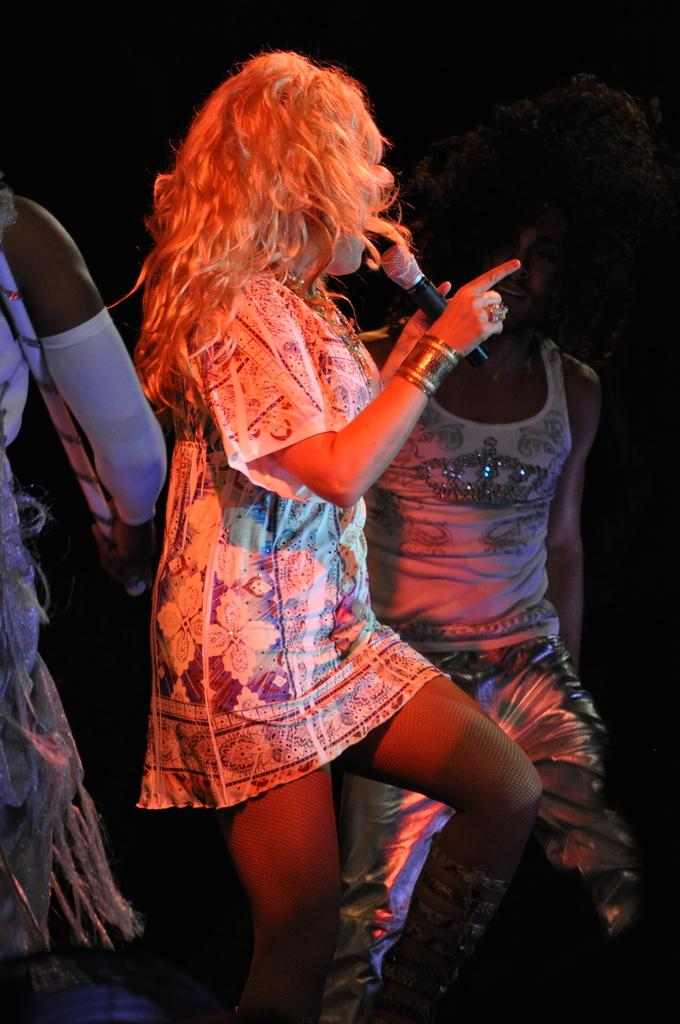How many people are in the image? There are a few people in the image. What is one person doing in the image? One person is holding a microphone. What can be observed about the background of the image? The background of the image is dark. Can you describe the object at the bottom left of the image? Unfortunately, the provided facts do not give any information about the object at the bottom left of the image. What type of popcorn is being served in the image? There is no popcorn present in the image. What color is the shirt of the person holding the microphone? The provided facts do not mention the color of the person's shirt. 